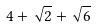Convert formula to latex. <formula><loc_0><loc_0><loc_500><loc_500>4 + \sqrt { 2 } + \sqrt { 6 }</formula> 